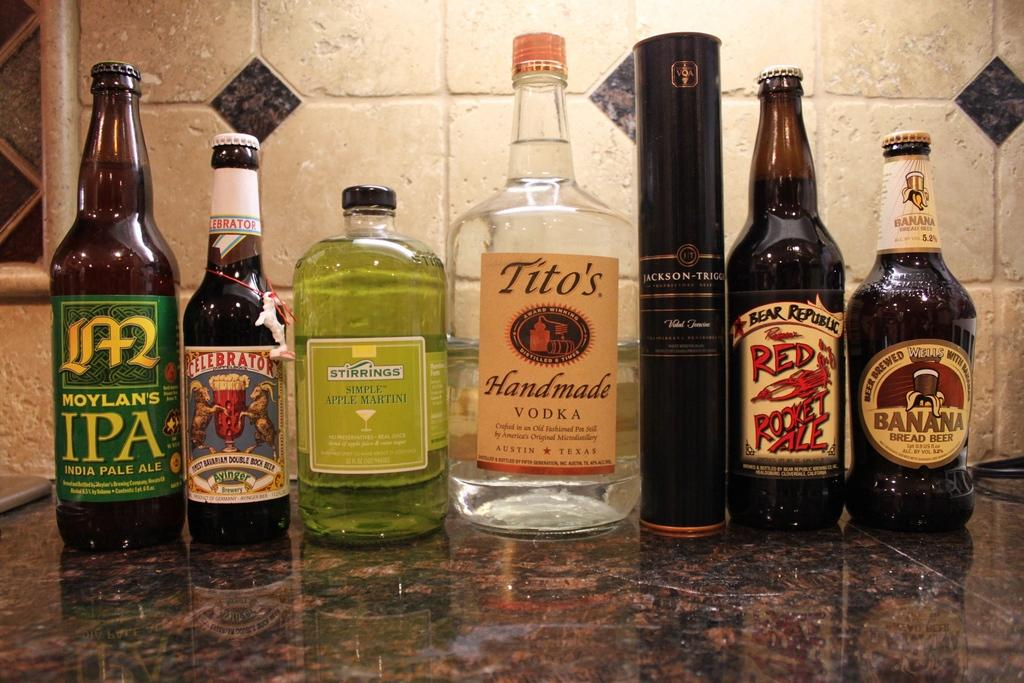<image>
Provide a brief description of the given image. A row of bottles of beer and vodka and mixer. 